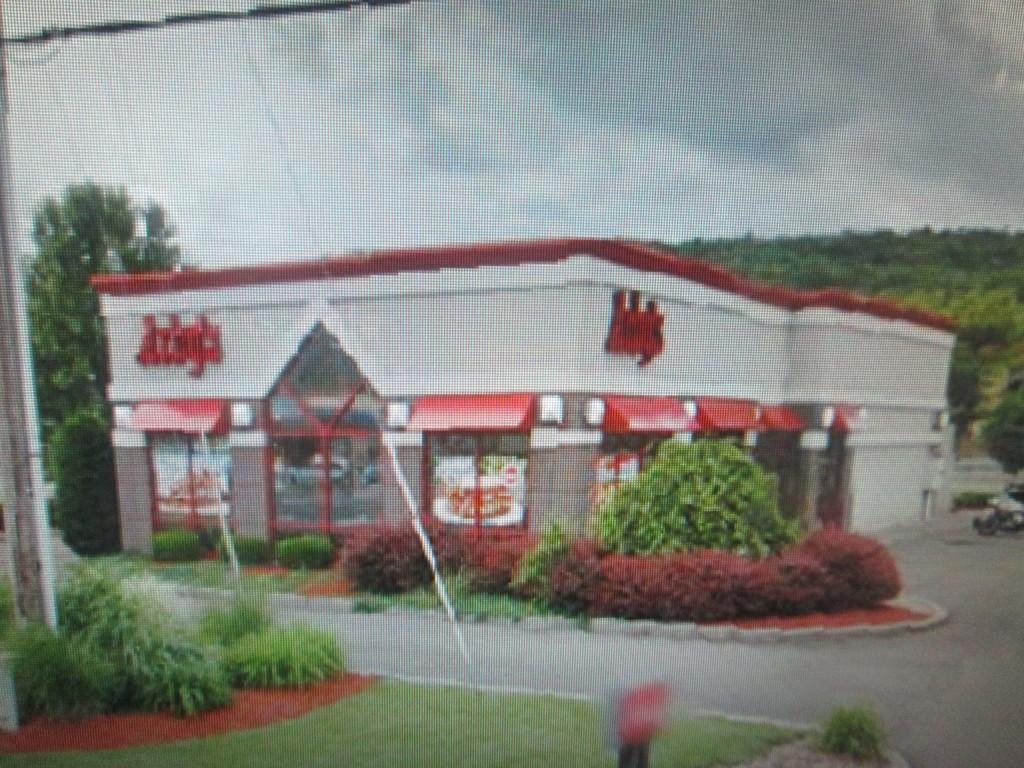Please provide a concise description of this image. In this image, I can see a building with glass doors. This is a name board attached to the building. I can see small bushes. This looks like a pole. These are the trees. Here is the grass. At the right corner of the image, that looks like a motorbike, which is parked. 